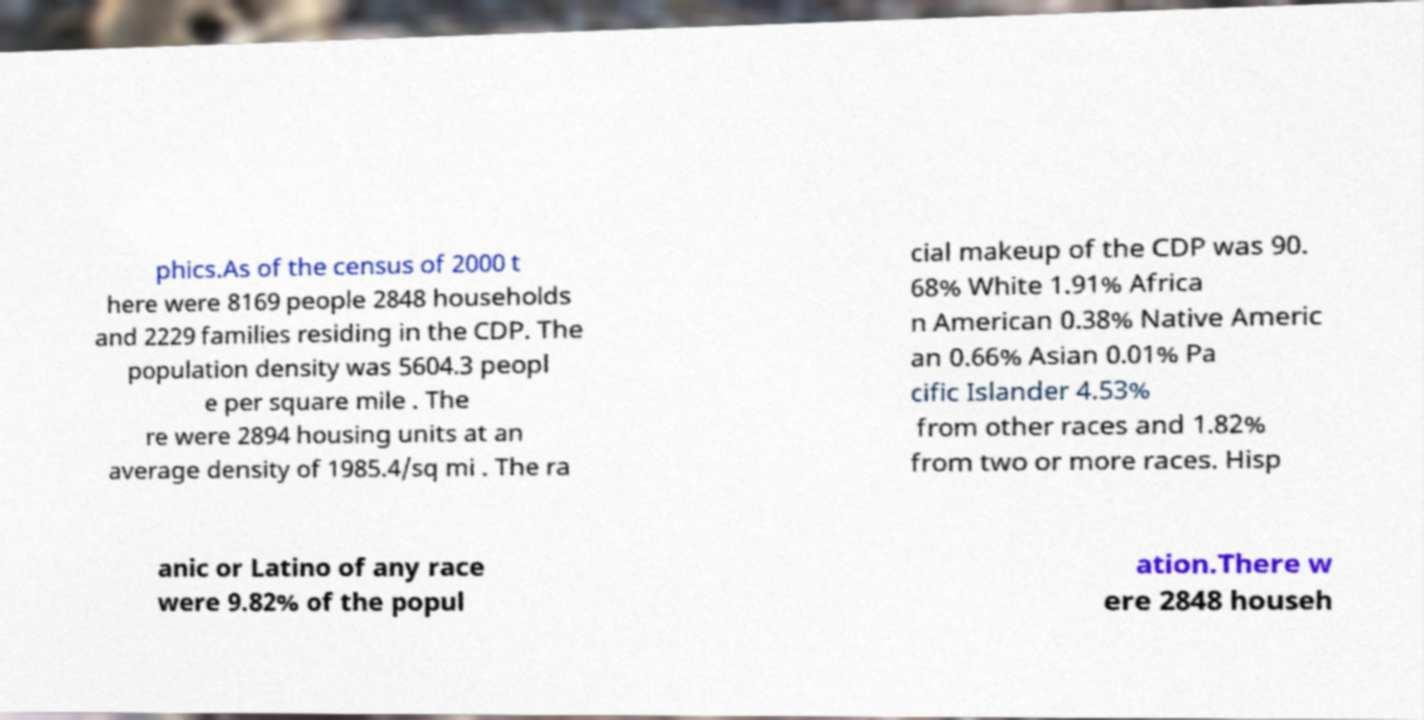I need the written content from this picture converted into text. Can you do that? phics.As of the census of 2000 t here were 8169 people 2848 households and 2229 families residing in the CDP. The population density was 5604.3 peopl e per square mile . The re were 2894 housing units at an average density of 1985.4/sq mi . The ra cial makeup of the CDP was 90. 68% White 1.91% Africa n American 0.38% Native Americ an 0.66% Asian 0.01% Pa cific Islander 4.53% from other races and 1.82% from two or more races. Hisp anic or Latino of any race were 9.82% of the popul ation.There w ere 2848 househ 